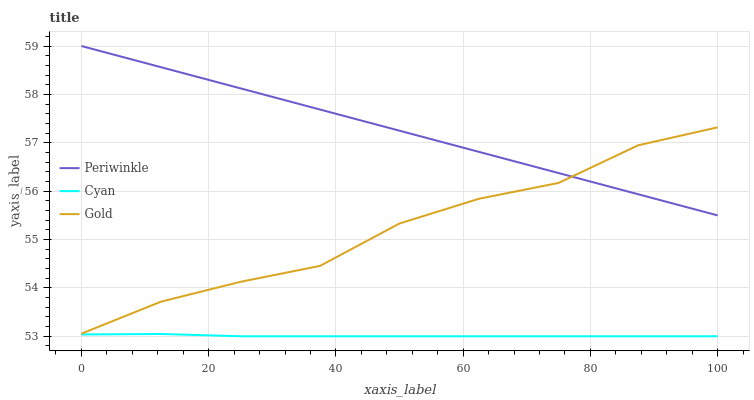Does Cyan have the minimum area under the curve?
Answer yes or no. Yes. Does Periwinkle have the maximum area under the curve?
Answer yes or no. Yes. Does Gold have the minimum area under the curve?
Answer yes or no. No. Does Gold have the maximum area under the curve?
Answer yes or no. No. Is Periwinkle the smoothest?
Answer yes or no. Yes. Is Gold the roughest?
Answer yes or no. Yes. Is Gold the smoothest?
Answer yes or no. No. Is Periwinkle the roughest?
Answer yes or no. No. Does Cyan have the lowest value?
Answer yes or no. Yes. Does Gold have the lowest value?
Answer yes or no. No. Does Periwinkle have the highest value?
Answer yes or no. Yes. Does Gold have the highest value?
Answer yes or no. No. Is Cyan less than Periwinkle?
Answer yes or no. Yes. Is Periwinkle greater than Cyan?
Answer yes or no. Yes. Does Gold intersect Periwinkle?
Answer yes or no. Yes. Is Gold less than Periwinkle?
Answer yes or no. No. Is Gold greater than Periwinkle?
Answer yes or no. No. Does Cyan intersect Periwinkle?
Answer yes or no. No. 